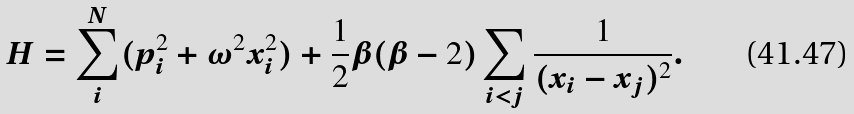Convert formula to latex. <formula><loc_0><loc_0><loc_500><loc_500>H = \sum _ { i } ^ { N } ( p _ { i } ^ { 2 } + \omega ^ { 2 } x _ { i } ^ { 2 } ) + \frac { 1 } { 2 } \beta ( \beta - 2 ) \sum _ { i < j } \frac { 1 } { ( x _ { i } - x _ { j } ) ^ { 2 } } .</formula> 